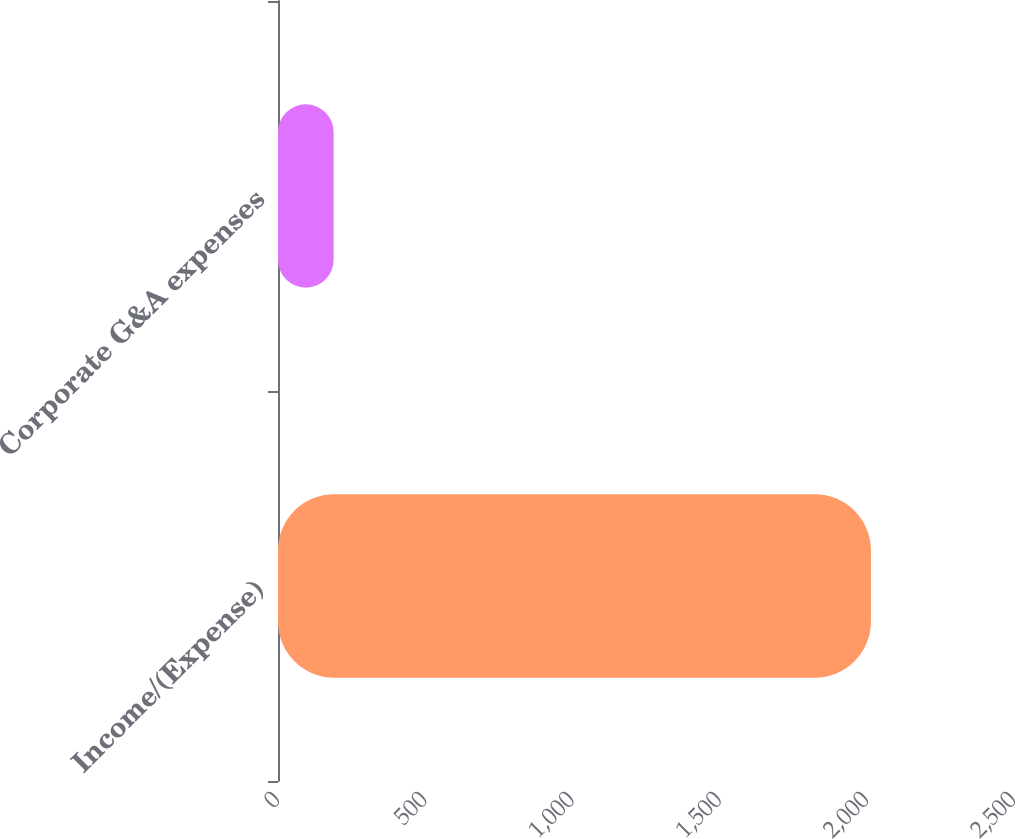Convert chart to OTSL. <chart><loc_0><loc_0><loc_500><loc_500><bar_chart><fcel>Income/(Expense)<fcel>Corporate G&A expenses<nl><fcel>2014<fcel>189<nl></chart> 